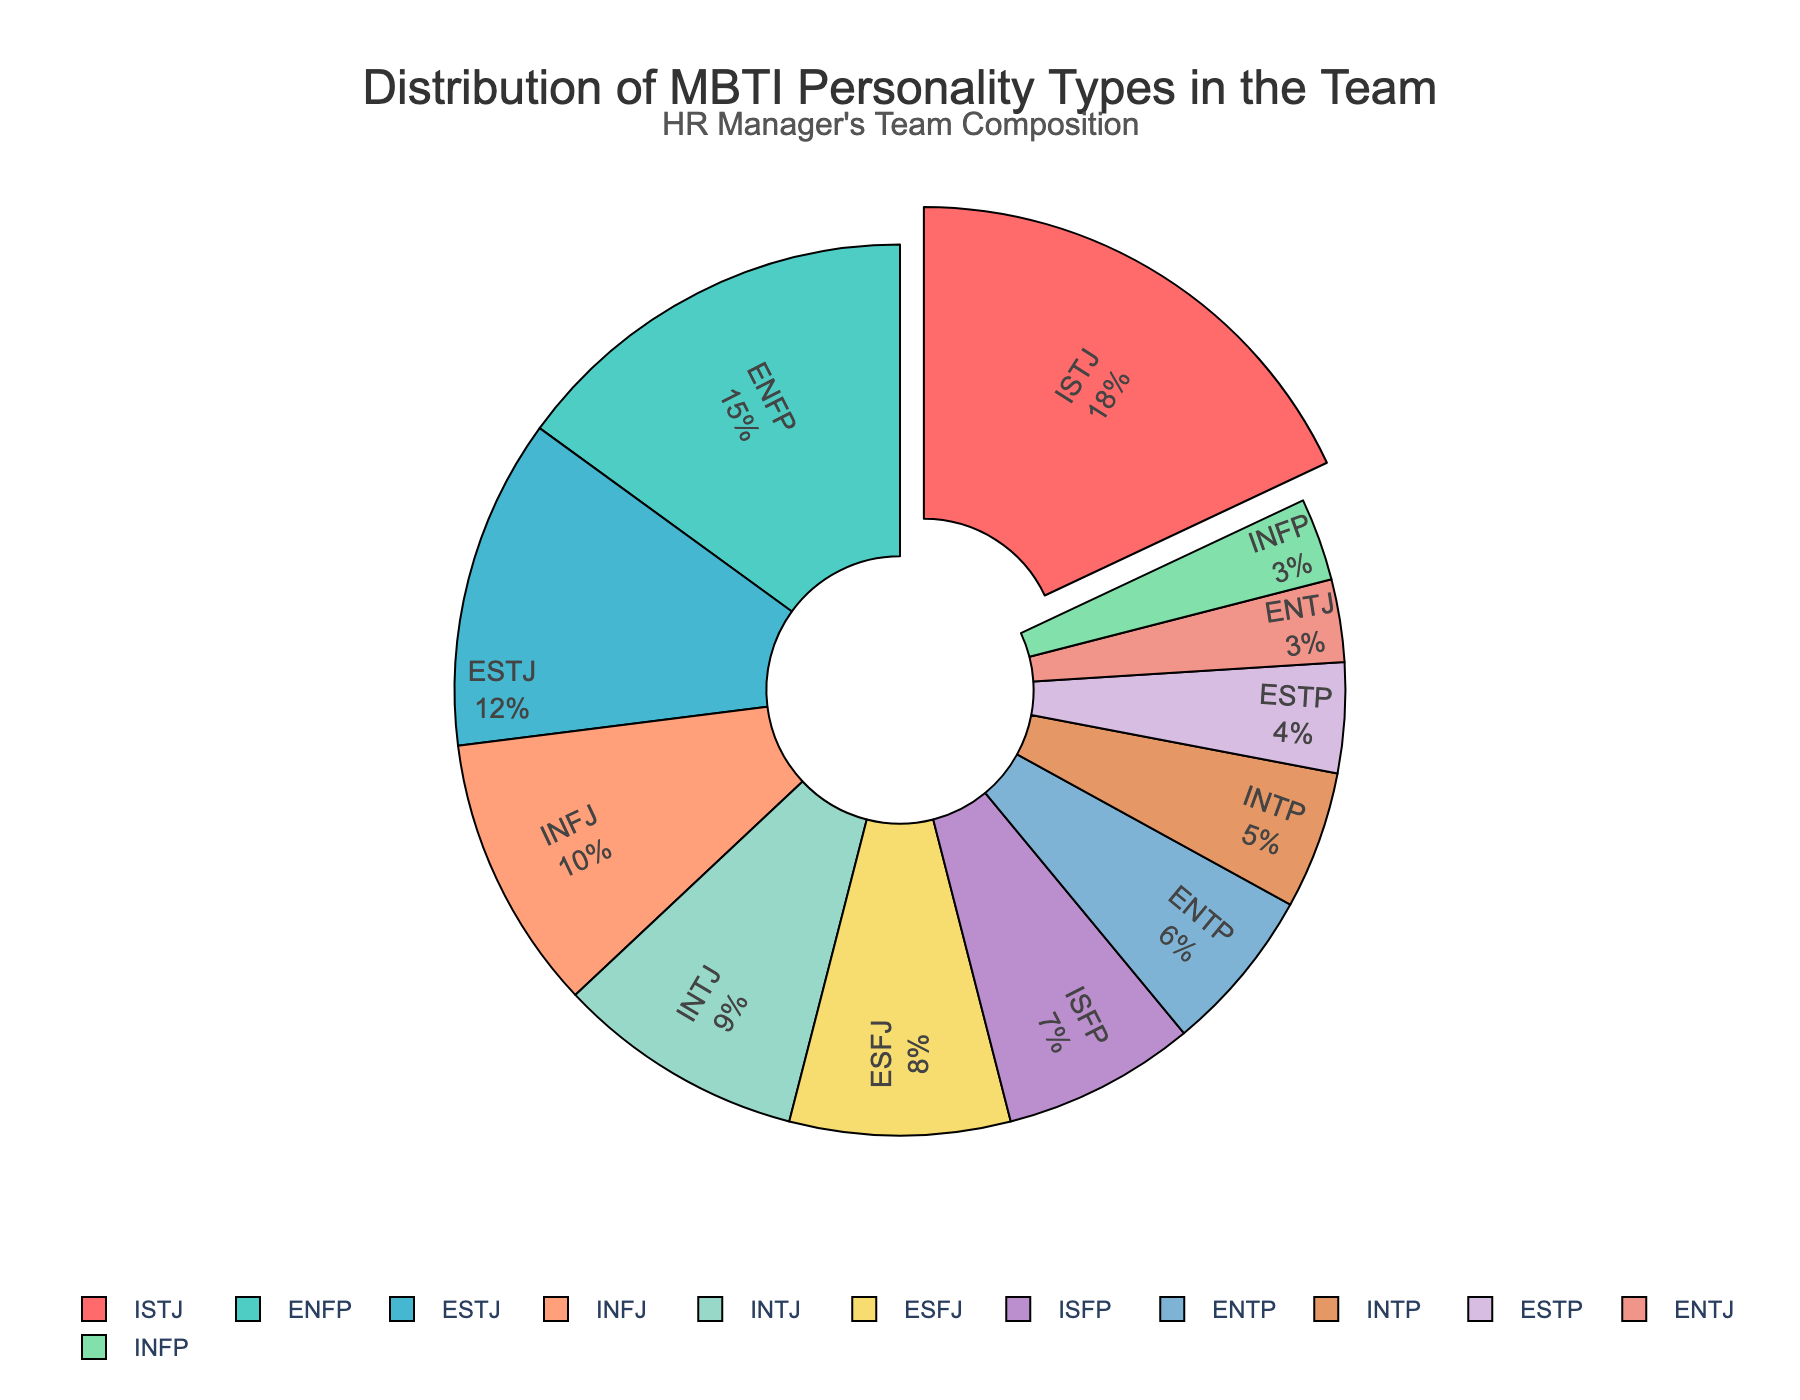What's the most common personality type in the team? To find the most common personality type, look for the personality type with the largest percentage in the pie chart. Here, ISTJ has the highest percentage at 18%.
Answer: ISTJ Which personality type has the second highest representation in the team? Observe the pie chart to identify the segment with the second-largest percentage. ENFP has 15%, which is the second highest.
Answer: ENFP How many personality types have a representation of less than 5%? Check the percentages of each segment and count those below 5%. The types with less than 5% representation are ESTP, ENTJ, and INFP.
Answer: 3 What's the combined percentage of INFJ and INTJ types? Add the percentages of INFJ (10%) and INTJ (9%). The combined percentage is 10 + 9 = 19%.
Answer: 19% How does the percentage of ESTJ compare to ESFJ? Compare the percentages of ESTJ (12%) and ESFJ (8%). ESTJ has a higher representation at 4% more.
Answer: ESTJ is 4% higher Which personality type is represented by the green segment, and what is its percentage? Identify the green segment in the chart. The green color represents the ESFJ personality type with a percentage of 8%.
Answer: ESFJ, 8% Is there a bigger difference between the percentage shares of ISTJ and ENFP or between ESTJ and INFJ? Calculate the differences: 
ISTJ and ENFP difference: 18% - 15% = 3%; 
ESTJ and INFJ difference: 12% - 10% = 2%. The difference between ISTJ and ENFP is larger.
Answer: Difference between ISTJ and ENFP is larger What is the smallest percentage of personality type in the team, and which types are they? Look for the smallest percentage indicated in the pie chart. Both ENTJ and INFP have the smallest percentage at 3%.
Answer: 3%, ENTJ and INFP What percentage of the team is comprised of intuitive (N) personality types? Sum the percentages of ENFP (15%), INFJ (10%), INTJ (9%), ENTP (6%), INTP (5%), ENTJ (3%), and INFP (3%). The total is 15 + 10 + 9 + 6 + 5 + 3 + 3 = 51%.
Answer: 51% How does the representation of thinking (T) types compare to feeling (F) types? Sum the percentages of thinking types (ISTJ 18%, ESTJ 12%, INTJ 9%, ENTP 6%, INTP 5%, ENTJ 3%, ESTP 4%) which equals 18+12+9+6+5+3+4 = 57%. Sum the feeling types (ENFP 15%, INFJ 10%, ESFJ 8%, ISFP 7%, and INFP 3%) which is 15+10+8+7+3 = 43%. Thinking types have a higher representation.
Answer: Thinking types: 57%, Feeling types: 43% 